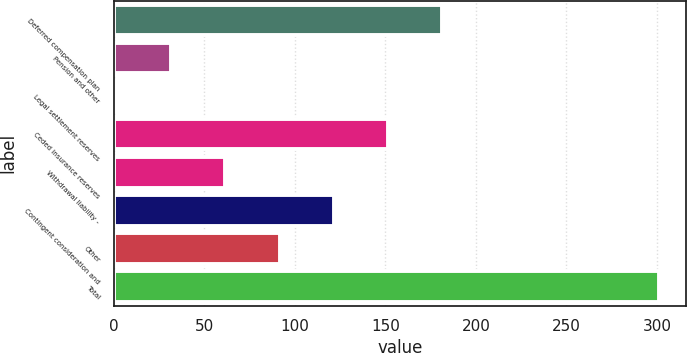Convert chart. <chart><loc_0><loc_0><loc_500><loc_500><bar_chart><fcel>Deferred compensation plan<fcel>Pension and other<fcel>Legal settlement reserves<fcel>Ceded insurance reserves<fcel>Withdrawal liability -<fcel>Contingent consideration and<fcel>Other<fcel>Total<nl><fcel>181.4<fcel>31.65<fcel>1.7<fcel>151.45<fcel>61.6<fcel>121.5<fcel>91.55<fcel>301.2<nl></chart> 